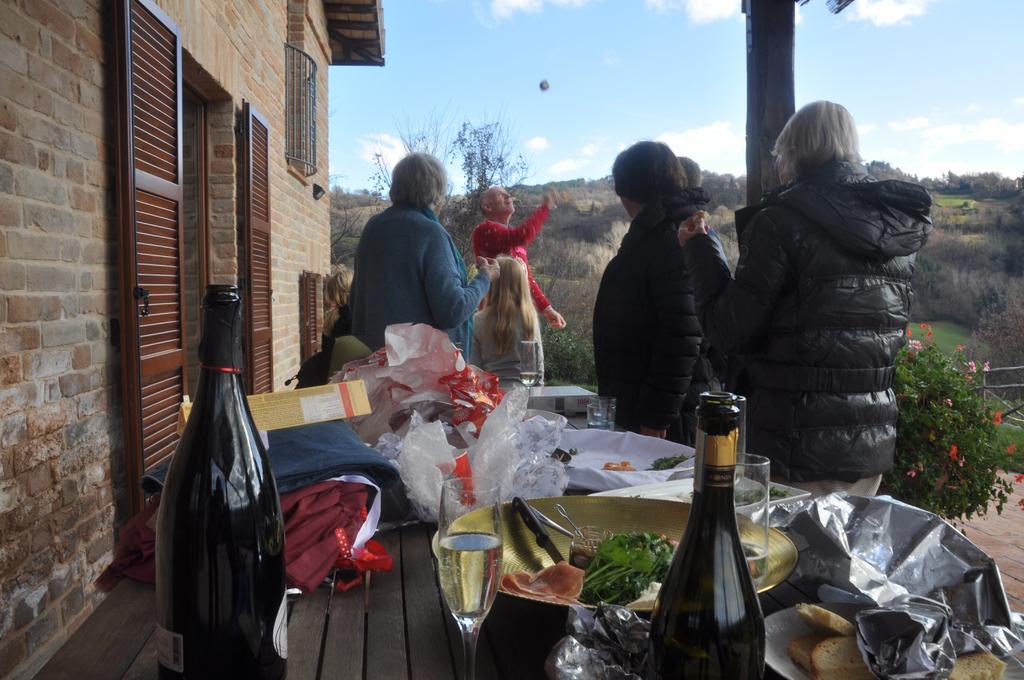How would you summarize this image in a sentence or two? In the foreground of the picture we can see people, table, bottles, glass, food items, boxes, covers and various objects. On the left we can see door, corridor, window and wall. In the middle of the picture we can see trees. On the right we can see plant, flowers, grass and other objects. At the top there is sky. 